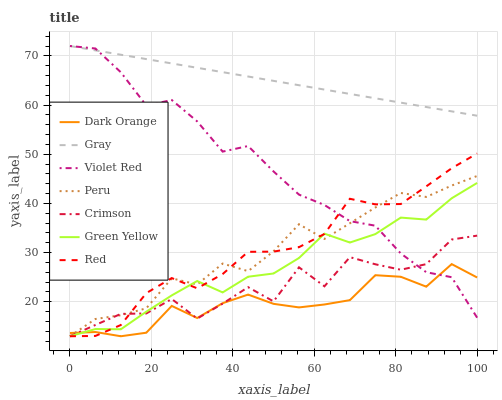Does Dark Orange have the minimum area under the curve?
Answer yes or no. Yes. Does Gray have the maximum area under the curve?
Answer yes or no. Yes. Does Violet Red have the minimum area under the curve?
Answer yes or no. No. Does Violet Red have the maximum area under the curve?
Answer yes or no. No. Is Gray the smoothest?
Answer yes or no. Yes. Is Crimson the roughest?
Answer yes or no. Yes. Is Violet Red the smoothest?
Answer yes or no. No. Is Violet Red the roughest?
Answer yes or no. No. Does Dark Orange have the lowest value?
Answer yes or no. Yes. Does Violet Red have the lowest value?
Answer yes or no. No. Does Gray have the highest value?
Answer yes or no. Yes. Does Peru have the highest value?
Answer yes or no. No. Is Peru less than Gray?
Answer yes or no. Yes. Is Gray greater than Red?
Answer yes or no. Yes. Does Green Yellow intersect Red?
Answer yes or no. Yes. Is Green Yellow less than Red?
Answer yes or no. No. Is Green Yellow greater than Red?
Answer yes or no. No. Does Peru intersect Gray?
Answer yes or no. No. 